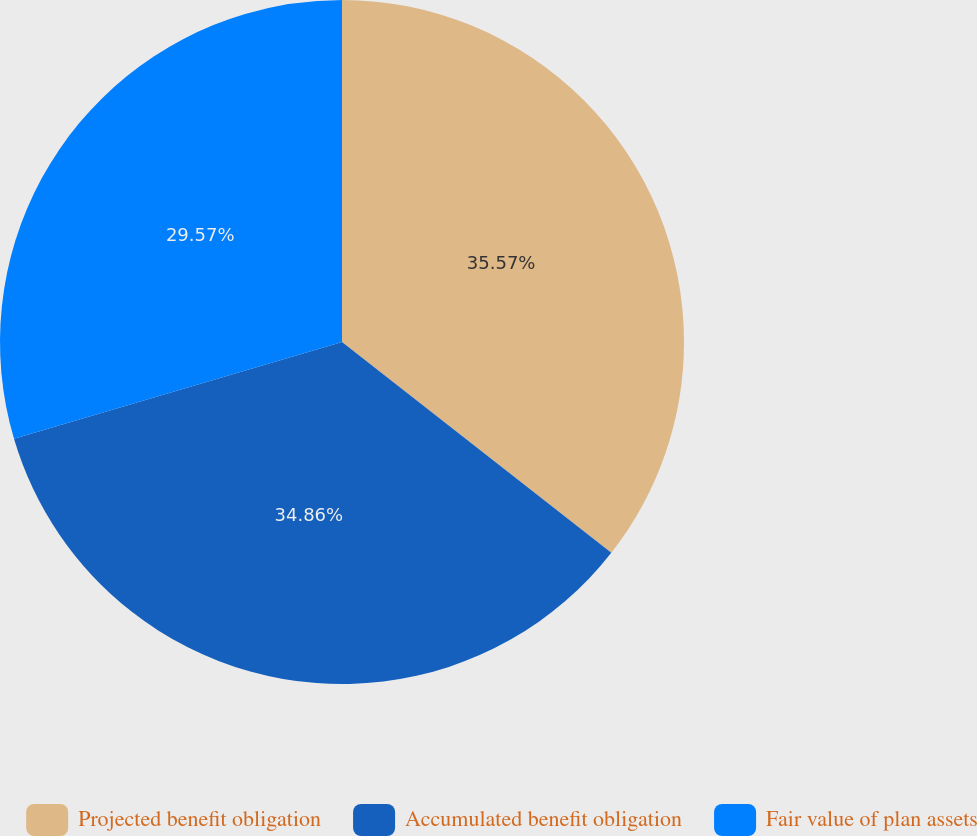<chart> <loc_0><loc_0><loc_500><loc_500><pie_chart><fcel>Projected benefit obligation<fcel>Accumulated benefit obligation<fcel>Fair value of plan assets<nl><fcel>35.57%<fcel>34.86%<fcel>29.57%<nl></chart> 